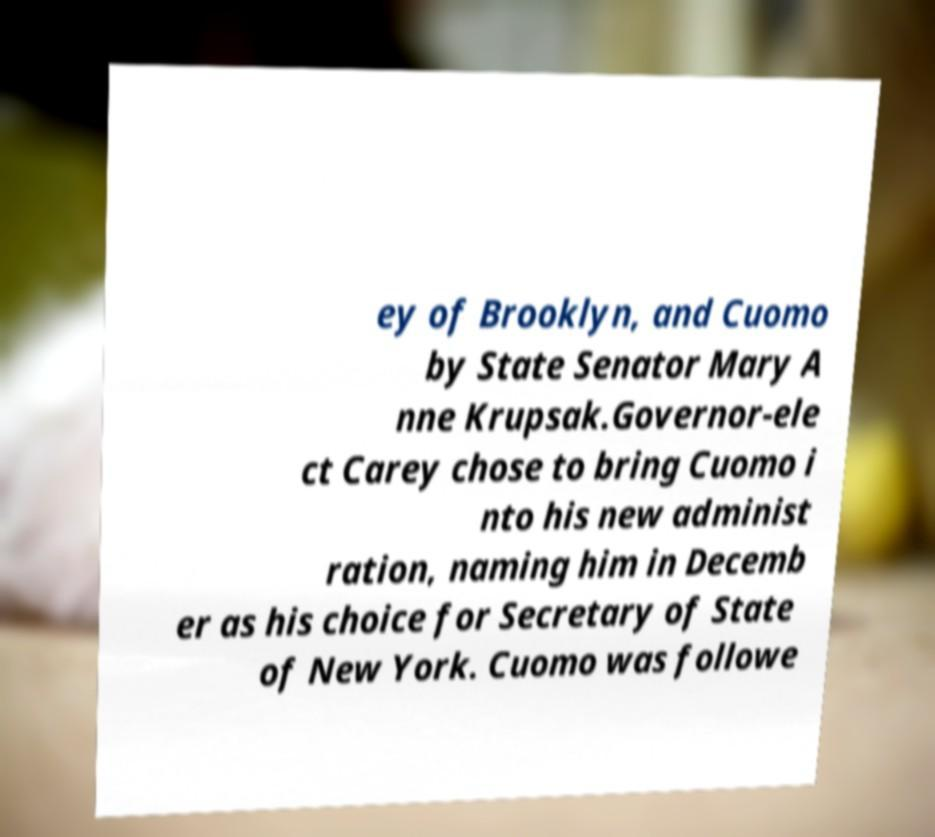Please read and relay the text visible in this image. What does it say? ey of Brooklyn, and Cuomo by State Senator Mary A nne Krupsak.Governor-ele ct Carey chose to bring Cuomo i nto his new administ ration, naming him in Decemb er as his choice for Secretary of State of New York. Cuomo was followe 